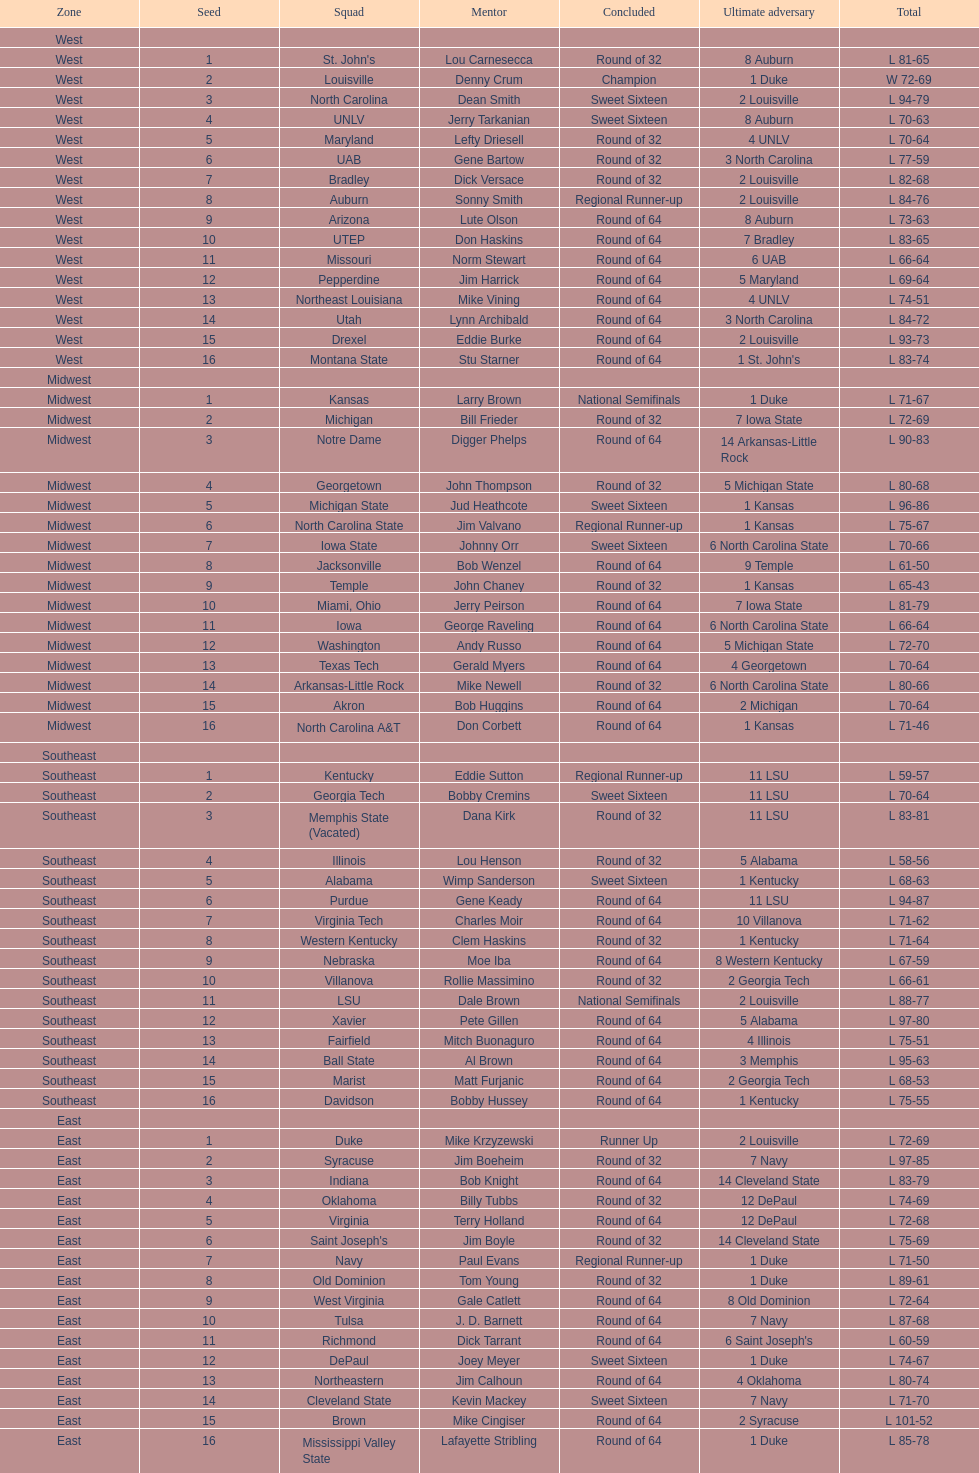How numerous are the 1 seeds? 4. 